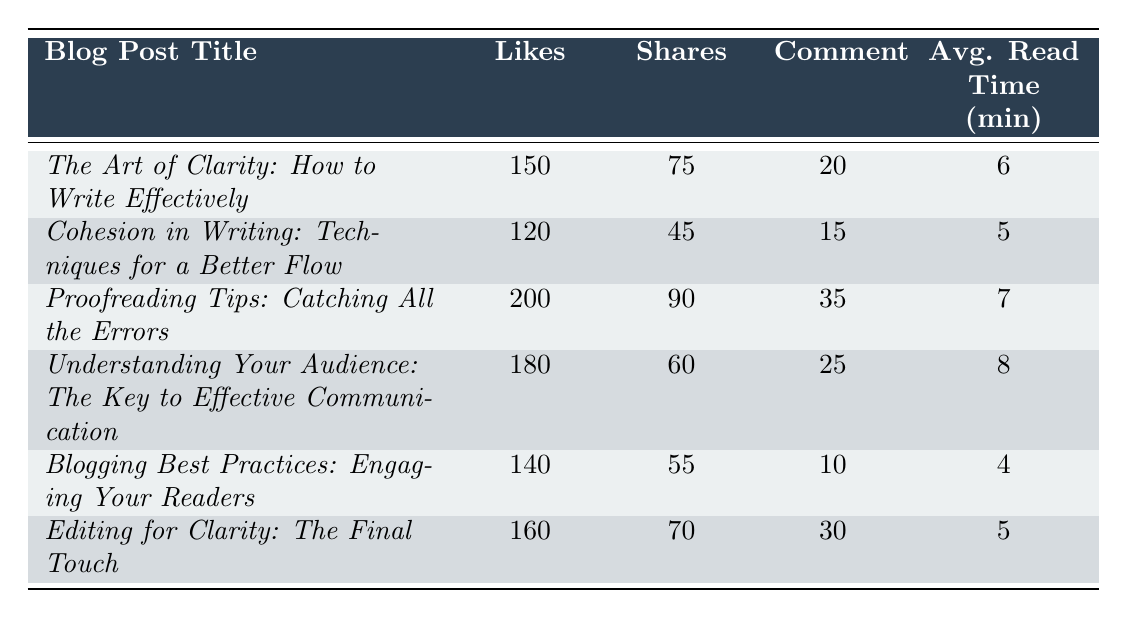What blog post received the highest number of likes? Looking at the "Likes" column, the blog post titled "*Proofreading Tips: Catching All the Errors*" has the highest value at 200.
Answer: Proofreading Tips: Catching All the Errors What is the average read time for the blog post titled "*Understanding Your Audience: The Key to Effective Communication*"? The table lists the average read time for that blog post as 8 minutes.
Answer: 8 minutes How many shares did "*Cohesion in Writing: Techniques for a Better Flow*" receive? The "Shares" column shows that this blog post received 45 shares.
Answer: 45 shares Did "*Blogging Best Practices: Engaging Your Readers*" receive more comments than "*Editing for Clarity: The Final Touch*"? "*Blogging Best Practices: Engaging Your Readers*" has 10 comments, whereas "*Editing for Clarity: The Final Touch*" has 30 comments, so it did not receive more.
Answer: No What is the total number of likes for all the blog posts combined? Adding the "Likes" values: 150 + 120 + 200 + 180 + 140 + 160 = 1,050.
Answer: 1,050 Which blog post has the highest engagement when considering likes, shares, and comments combined? For "*Proofreading Tips: Catching All the Errors*", engagement = 200 + 90 + 35 = 325. For "*Understanding Your Audience: The Key to Effective Communication*", engagement = 180 + 60 + 25 = 265. Hence, "*Proofreading Tips: Catching All the Errors*" has the highest combined engagement.
Answer: Proofreading Tips: Catching All the Errors What is the difference in average read time between the blog post with the highest read time and the one with the lowest? The highest average read time is 8 minutes and the lowest is 4 minutes (from "*Blogging Best Practices: Engaging Your Readers*"). The difference is 8 - 4 = 4 minutes.
Answer: 4 minutes Which blog post received the least number of shares? From the "Shares" column, "*Cohesion in Writing: Techniques for a Better Flow*" has the lowest number of shares, which is 45.
Answer: Cohesion in Writing: Techniques for a Better Flow What was the average number of comments across all blog posts? Sum of comments: 20 + 15 + 35 + 25 + 10 + 30 = 135. There are 6 posts, so average = 135 / 6 = 22.5.
Answer: 22.5 comments 